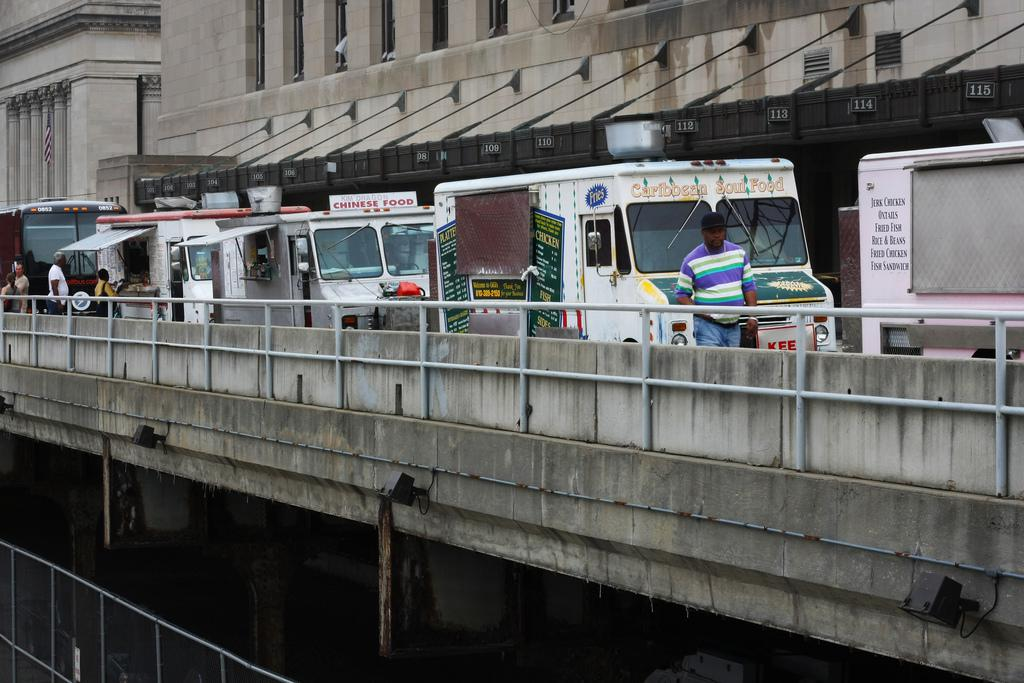Question: where are there signs?
Choices:
A. On the cars.
B. On the train.
C. On the plane.
D. On the trucks.
Answer with the letter. Answer: D Question: what is the building made of?
Choices:
A. Bricks.
B. Cement.
C. Wood.
D. Glass.
Answer with the letter. Answer: B Question: what are the cars doing?
Choices:
A. Driving.
B. Parking.
C. Idling.
D. Selling foods.
Answer with the letter. Answer: D Question: how is the weather?
Choices:
A. Sunny.
B. Warm.
C. Cloudy.
D. Windy.
Answer with the letter. Answer: C Question: how many people are there?
Choices:
A. 4.
B. 1.
C. 2.
D. 3.
Answer with the letter. Answer: A Question: what color is the wall of building?
Choices:
A. Blue.
B. Brown.
C. Red.
D. Tan.
Answer with the letter. Answer: B Question: what is the man doing?
Choices:
A. Crossing a bridge.
B. Walking.
C. Going somewhere.
D. Swimming.
Answer with the letter. Answer: A Question: where is a line of traffic going?
Choices:
A. Across the bridge.
B. Down the way.
C. Through town.
D. Into the country.
Answer with the letter. Answer: A Question: what is lined up on the bridge?
Choices:
A. Dump trucks.
B. Cars.
C. Buses.
D. Food trucks.
Answer with the letter. Answer: D Question: who is wearing a striped shirt?
Choices:
A. The young child.
B. The older woman.
C. The construction worker.
D. Man.
Answer with the letter. Answer: D Question: what color of hat is the guy wearing?
Choices:
A. Green.
B. Black.
C. Red.
D. Blue.
Answer with the letter. Answer: B Question: where are the fences?
Choices:
A. Below the bridge.
B. Around the house.
C. Near the river.
D. At the market's entrance.
Answer with the letter. Answer: A Question: what does the concrete building have a lot of?
Choices:
A. Doors.
B. Store rooms.
C. Class rooms.
D. Windows.
Answer with the letter. Answer: D 